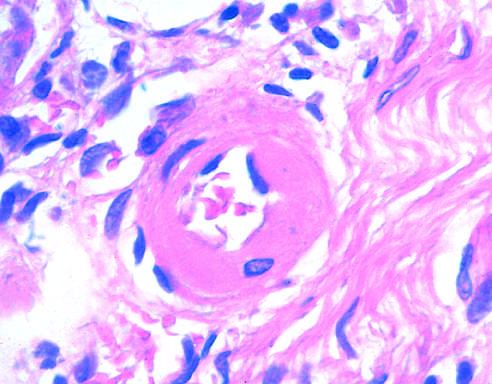s edema thickened with the deposition of amorphous proteinaceous material hyalinized?
Answer the question using a single word or phrase. No 